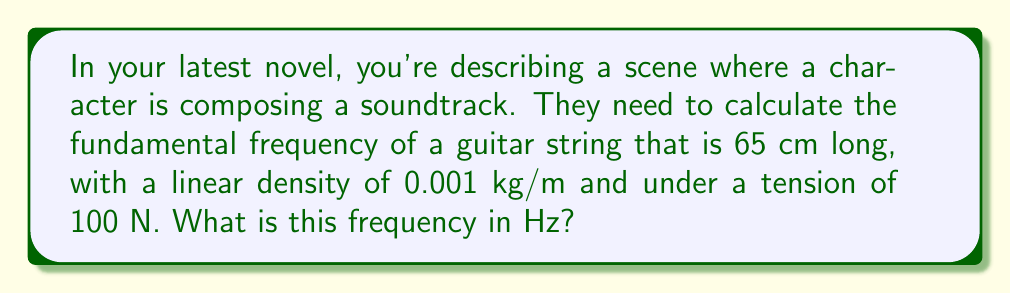Could you help me with this problem? To solve this problem, we'll use the wave equation for a vibrating string. The fundamental frequency of a vibrating string is given by:

$$ f = \frac{1}{2L} \sqrt{\frac{T}{\mu}} $$

Where:
$f$ = fundamental frequency (Hz)
$L$ = length of the string (m)
$T$ = tension in the string (N)
$\mu$ = linear density of the string (kg/m)

Let's plug in the given values:

$L = 65 \text{ cm} = 0.65 \text{ m}$
$T = 100 \text{ N}$
$\mu = 0.001 \text{ kg/m}$

Now, let's calculate:

$$ f = \frac{1}{2(0.65)} \sqrt{\frac{100}{0.001}} $$

$$ f = \frac{1}{1.3} \sqrt{100000} $$

$$ f = \frac{1}{1.3} (316.23) $$

$$ f \approx 243.25 \text{ Hz} $$

Rounding to the nearest whole number, we get 243 Hz.
Answer: 243 Hz 